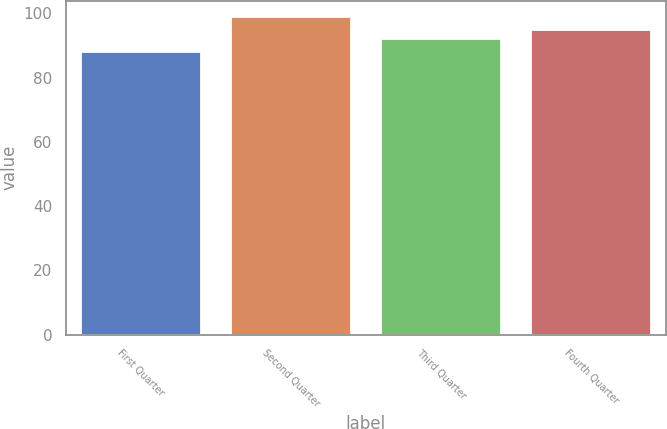<chart> <loc_0><loc_0><loc_500><loc_500><bar_chart><fcel>First Quarter<fcel>Second Quarter<fcel>Third Quarter<fcel>Fourth Quarter<nl><fcel>88<fcel>98.99<fcel>91.95<fcel>94.8<nl></chart> 